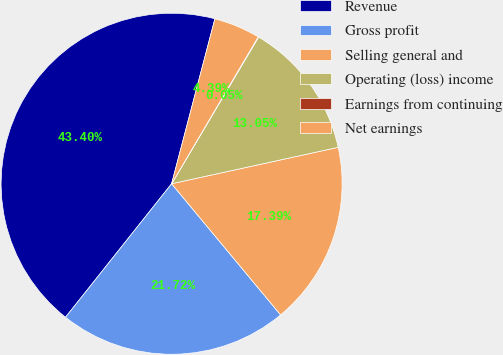Convert chart. <chart><loc_0><loc_0><loc_500><loc_500><pie_chart><fcel>Revenue<fcel>Gross profit<fcel>Selling general and<fcel>Operating (loss) income<fcel>Earnings from continuing<fcel>Net earnings<nl><fcel>43.4%<fcel>21.72%<fcel>17.39%<fcel>13.05%<fcel>0.05%<fcel>4.39%<nl></chart> 